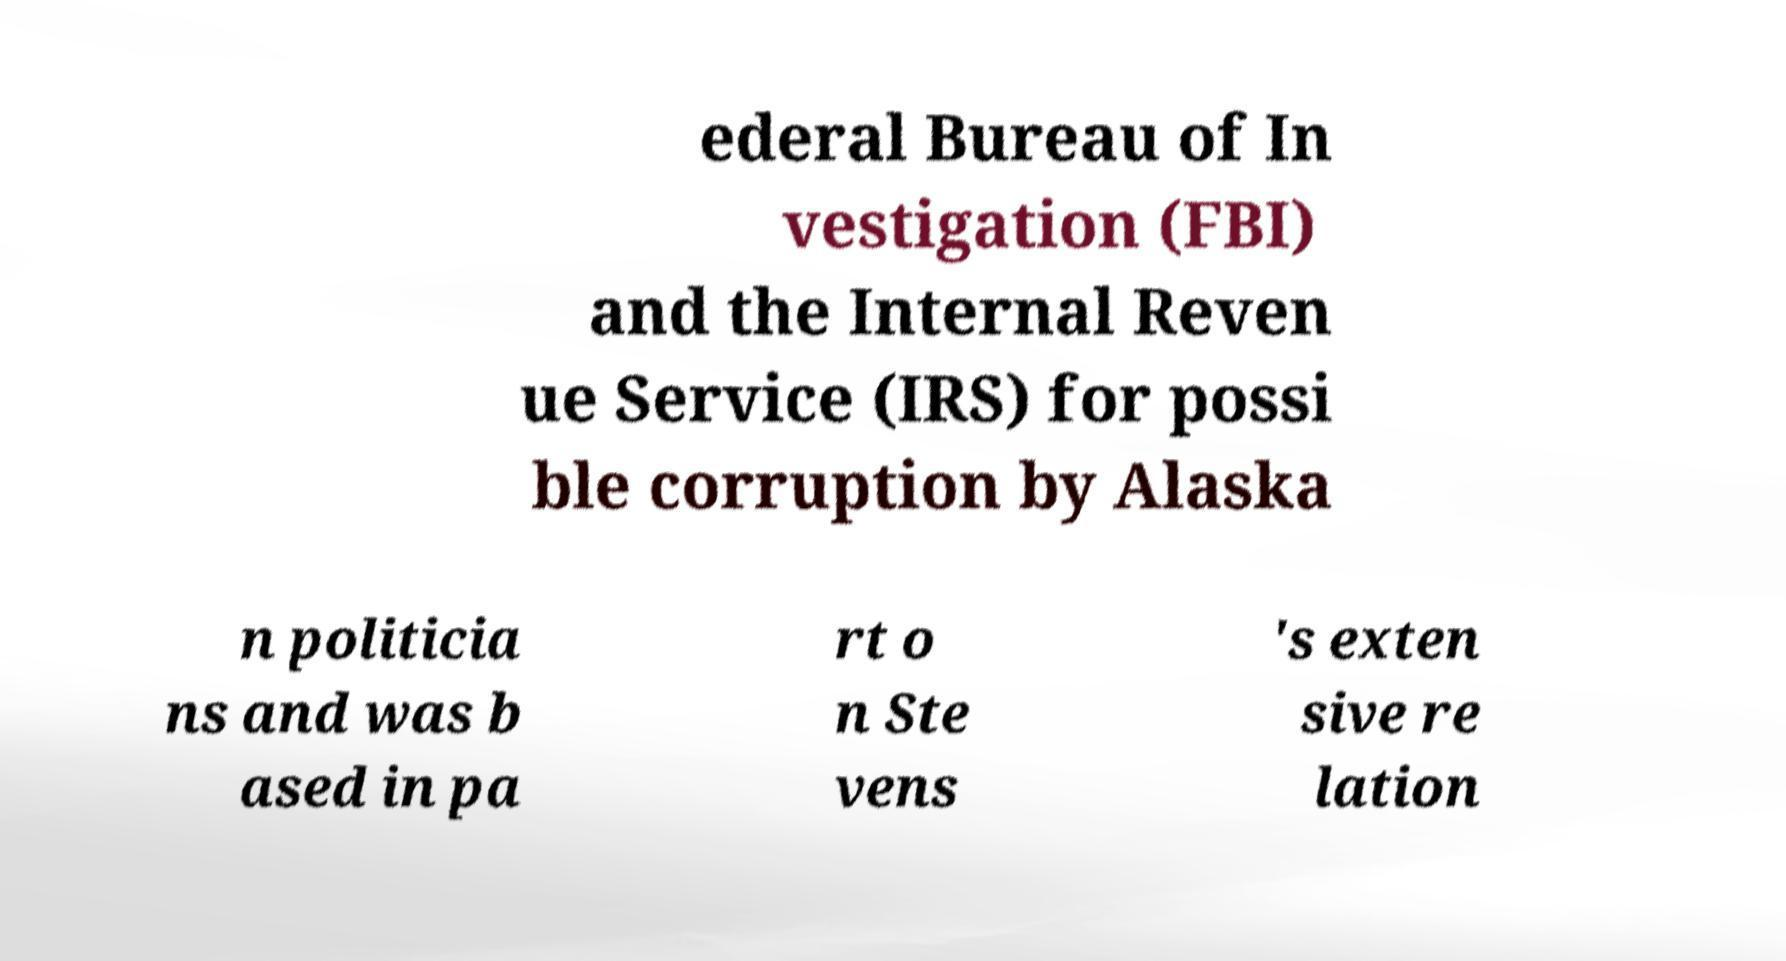I need the written content from this picture converted into text. Can you do that? ederal Bureau of In vestigation (FBI) and the Internal Reven ue Service (IRS) for possi ble corruption by Alaska n politicia ns and was b ased in pa rt o n Ste vens 's exten sive re lation 